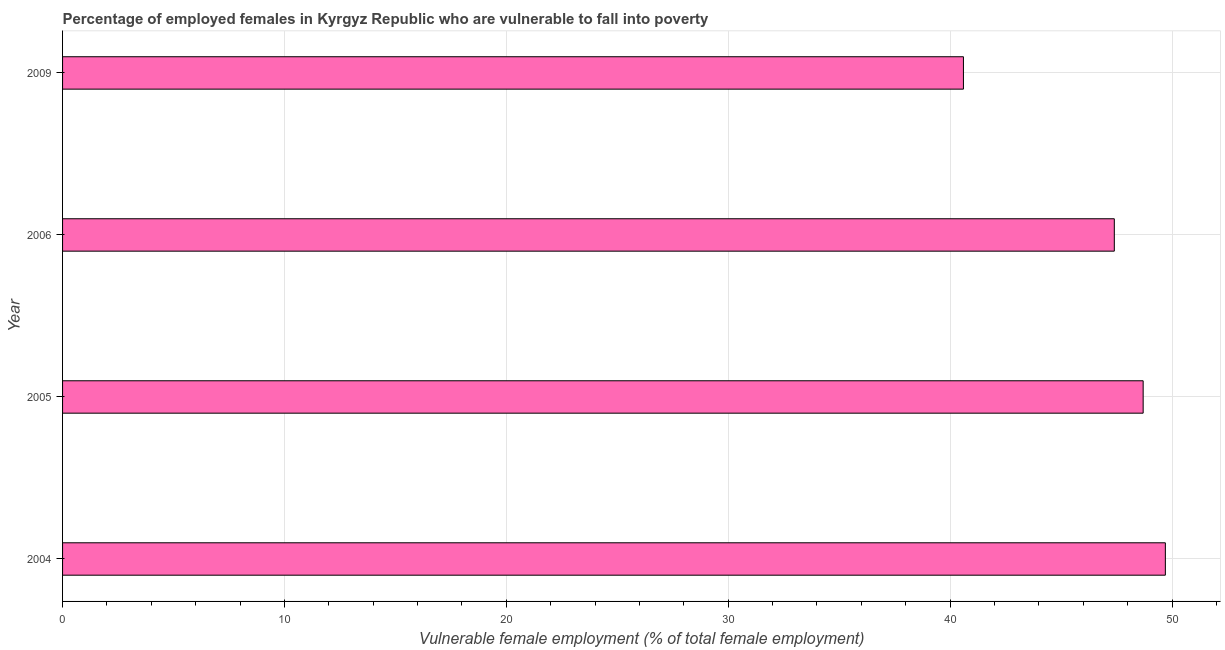Does the graph contain any zero values?
Offer a very short reply. No. Does the graph contain grids?
Provide a short and direct response. Yes. What is the title of the graph?
Give a very brief answer. Percentage of employed females in Kyrgyz Republic who are vulnerable to fall into poverty. What is the label or title of the X-axis?
Offer a terse response. Vulnerable female employment (% of total female employment). What is the label or title of the Y-axis?
Your response must be concise. Year. What is the percentage of employed females who are vulnerable to fall into poverty in 2009?
Offer a very short reply. 40.6. Across all years, what is the maximum percentage of employed females who are vulnerable to fall into poverty?
Offer a terse response. 49.7. Across all years, what is the minimum percentage of employed females who are vulnerable to fall into poverty?
Your answer should be compact. 40.6. In which year was the percentage of employed females who are vulnerable to fall into poverty maximum?
Offer a terse response. 2004. In which year was the percentage of employed females who are vulnerable to fall into poverty minimum?
Ensure brevity in your answer.  2009. What is the sum of the percentage of employed females who are vulnerable to fall into poverty?
Give a very brief answer. 186.4. What is the difference between the percentage of employed females who are vulnerable to fall into poverty in 2004 and 2009?
Make the answer very short. 9.1. What is the average percentage of employed females who are vulnerable to fall into poverty per year?
Provide a succinct answer. 46.6. What is the median percentage of employed females who are vulnerable to fall into poverty?
Make the answer very short. 48.05. Do a majority of the years between 2004 and 2005 (inclusive) have percentage of employed females who are vulnerable to fall into poverty greater than 18 %?
Ensure brevity in your answer.  Yes. What is the ratio of the percentage of employed females who are vulnerable to fall into poverty in 2004 to that in 2009?
Your response must be concise. 1.22. Is the percentage of employed females who are vulnerable to fall into poverty in 2005 less than that in 2009?
Give a very brief answer. No. Is the difference between the percentage of employed females who are vulnerable to fall into poverty in 2005 and 2009 greater than the difference between any two years?
Make the answer very short. No. What is the difference between the highest and the second highest percentage of employed females who are vulnerable to fall into poverty?
Ensure brevity in your answer.  1. What is the difference between the highest and the lowest percentage of employed females who are vulnerable to fall into poverty?
Your answer should be very brief. 9.1. How many bars are there?
Provide a succinct answer. 4. Are all the bars in the graph horizontal?
Offer a very short reply. Yes. How many years are there in the graph?
Offer a terse response. 4. What is the Vulnerable female employment (% of total female employment) in 2004?
Your response must be concise. 49.7. What is the Vulnerable female employment (% of total female employment) in 2005?
Your answer should be compact. 48.7. What is the Vulnerable female employment (% of total female employment) in 2006?
Your answer should be very brief. 47.4. What is the Vulnerable female employment (% of total female employment) in 2009?
Give a very brief answer. 40.6. What is the difference between the Vulnerable female employment (% of total female employment) in 2004 and 2006?
Provide a succinct answer. 2.3. What is the difference between the Vulnerable female employment (% of total female employment) in 2006 and 2009?
Offer a very short reply. 6.8. What is the ratio of the Vulnerable female employment (% of total female employment) in 2004 to that in 2005?
Provide a succinct answer. 1.02. What is the ratio of the Vulnerable female employment (% of total female employment) in 2004 to that in 2006?
Offer a very short reply. 1.05. What is the ratio of the Vulnerable female employment (% of total female employment) in 2004 to that in 2009?
Your answer should be compact. 1.22. What is the ratio of the Vulnerable female employment (% of total female employment) in 2005 to that in 2006?
Your response must be concise. 1.03. What is the ratio of the Vulnerable female employment (% of total female employment) in 2006 to that in 2009?
Offer a very short reply. 1.17. 